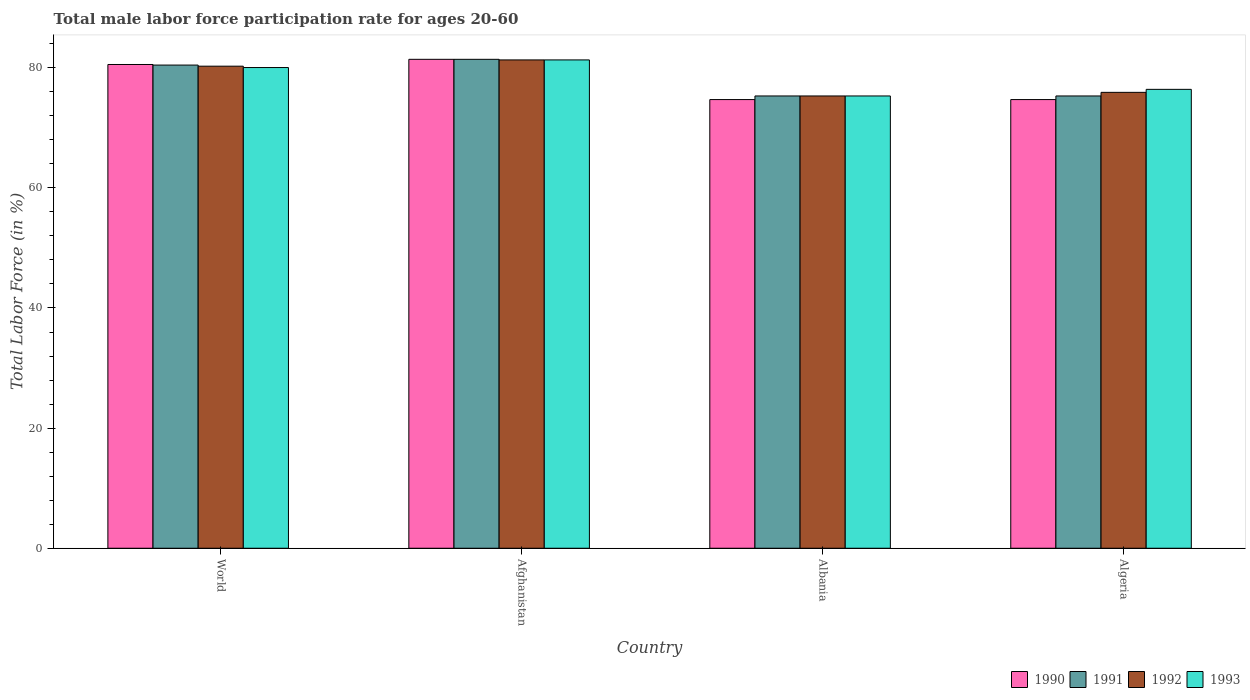How many groups of bars are there?
Provide a succinct answer. 4. Are the number of bars on each tick of the X-axis equal?
Keep it short and to the point. Yes. How many bars are there on the 4th tick from the right?
Your answer should be compact. 4. What is the label of the 3rd group of bars from the left?
Keep it short and to the point. Albania. In how many cases, is the number of bars for a given country not equal to the number of legend labels?
Make the answer very short. 0. What is the male labor force participation rate in 1991 in World?
Offer a terse response. 80.44. Across all countries, what is the maximum male labor force participation rate in 1993?
Offer a very short reply. 81.3. Across all countries, what is the minimum male labor force participation rate in 1990?
Offer a very short reply. 74.7. In which country was the male labor force participation rate in 1993 maximum?
Give a very brief answer. Afghanistan. In which country was the male labor force participation rate in 1992 minimum?
Keep it short and to the point. Albania. What is the total male labor force participation rate in 1992 in the graph?
Provide a succinct answer. 312.76. What is the difference between the male labor force participation rate in 1990 in Algeria and that in World?
Your answer should be very brief. -5.84. What is the difference between the male labor force participation rate in 1990 in World and the male labor force participation rate in 1992 in Albania?
Provide a succinct answer. 5.24. What is the average male labor force participation rate in 1993 per country?
Ensure brevity in your answer.  78.26. What is the difference between the male labor force participation rate of/in 1991 and male labor force participation rate of/in 1992 in Algeria?
Ensure brevity in your answer.  -0.6. In how many countries, is the male labor force participation rate in 1991 greater than 80 %?
Give a very brief answer. 2. What is the ratio of the male labor force participation rate in 1992 in Afghanistan to that in Albania?
Keep it short and to the point. 1.08. Is the male labor force participation rate in 1993 in Algeria less than that in World?
Your answer should be very brief. Yes. What is the difference between the highest and the second highest male labor force participation rate in 1991?
Your response must be concise. -0.96. In how many countries, is the male labor force participation rate in 1993 greater than the average male labor force participation rate in 1993 taken over all countries?
Give a very brief answer. 2. Is it the case that in every country, the sum of the male labor force participation rate in 1990 and male labor force participation rate in 1992 is greater than the sum of male labor force participation rate in 1991 and male labor force participation rate in 1993?
Keep it short and to the point. No. What does the 4th bar from the right in Albania represents?
Your answer should be very brief. 1990. How many countries are there in the graph?
Your response must be concise. 4. What is the difference between two consecutive major ticks on the Y-axis?
Ensure brevity in your answer.  20. Are the values on the major ticks of Y-axis written in scientific E-notation?
Keep it short and to the point. No. Does the graph contain any zero values?
Your answer should be very brief. No. How are the legend labels stacked?
Offer a terse response. Horizontal. What is the title of the graph?
Give a very brief answer. Total male labor force participation rate for ages 20-60. What is the label or title of the Y-axis?
Your answer should be compact. Total Labor Force (in %). What is the Total Labor Force (in %) of 1990 in World?
Your answer should be very brief. 80.54. What is the Total Labor Force (in %) in 1991 in World?
Offer a very short reply. 80.44. What is the Total Labor Force (in %) in 1992 in World?
Offer a terse response. 80.26. What is the Total Labor Force (in %) in 1993 in World?
Your answer should be very brief. 80.03. What is the Total Labor Force (in %) in 1990 in Afghanistan?
Your response must be concise. 81.4. What is the Total Labor Force (in %) in 1991 in Afghanistan?
Provide a succinct answer. 81.4. What is the Total Labor Force (in %) of 1992 in Afghanistan?
Offer a very short reply. 81.3. What is the Total Labor Force (in %) in 1993 in Afghanistan?
Your answer should be compact. 81.3. What is the Total Labor Force (in %) in 1990 in Albania?
Your answer should be very brief. 74.7. What is the Total Labor Force (in %) in 1991 in Albania?
Your answer should be compact. 75.3. What is the Total Labor Force (in %) in 1992 in Albania?
Your answer should be compact. 75.3. What is the Total Labor Force (in %) in 1993 in Albania?
Give a very brief answer. 75.3. What is the Total Labor Force (in %) in 1990 in Algeria?
Your answer should be very brief. 74.7. What is the Total Labor Force (in %) of 1991 in Algeria?
Your answer should be very brief. 75.3. What is the Total Labor Force (in %) in 1992 in Algeria?
Your answer should be very brief. 75.9. What is the Total Labor Force (in %) in 1993 in Algeria?
Ensure brevity in your answer.  76.4. Across all countries, what is the maximum Total Labor Force (in %) of 1990?
Your answer should be compact. 81.4. Across all countries, what is the maximum Total Labor Force (in %) in 1991?
Give a very brief answer. 81.4. Across all countries, what is the maximum Total Labor Force (in %) in 1992?
Offer a terse response. 81.3. Across all countries, what is the maximum Total Labor Force (in %) in 1993?
Give a very brief answer. 81.3. Across all countries, what is the minimum Total Labor Force (in %) of 1990?
Your response must be concise. 74.7. Across all countries, what is the minimum Total Labor Force (in %) in 1991?
Offer a terse response. 75.3. Across all countries, what is the minimum Total Labor Force (in %) in 1992?
Offer a terse response. 75.3. Across all countries, what is the minimum Total Labor Force (in %) of 1993?
Make the answer very short. 75.3. What is the total Total Labor Force (in %) of 1990 in the graph?
Your response must be concise. 311.34. What is the total Total Labor Force (in %) in 1991 in the graph?
Offer a very short reply. 312.44. What is the total Total Labor Force (in %) of 1992 in the graph?
Give a very brief answer. 312.76. What is the total Total Labor Force (in %) of 1993 in the graph?
Provide a short and direct response. 313.03. What is the difference between the Total Labor Force (in %) in 1990 in World and that in Afghanistan?
Provide a succinct answer. -0.86. What is the difference between the Total Labor Force (in %) of 1991 in World and that in Afghanistan?
Your response must be concise. -0.96. What is the difference between the Total Labor Force (in %) of 1992 in World and that in Afghanistan?
Your response must be concise. -1.04. What is the difference between the Total Labor Force (in %) in 1993 in World and that in Afghanistan?
Offer a terse response. -1.27. What is the difference between the Total Labor Force (in %) of 1990 in World and that in Albania?
Provide a succinct answer. 5.84. What is the difference between the Total Labor Force (in %) of 1991 in World and that in Albania?
Make the answer very short. 5.14. What is the difference between the Total Labor Force (in %) of 1992 in World and that in Albania?
Make the answer very short. 4.96. What is the difference between the Total Labor Force (in %) of 1993 in World and that in Albania?
Keep it short and to the point. 4.73. What is the difference between the Total Labor Force (in %) of 1990 in World and that in Algeria?
Give a very brief answer. 5.84. What is the difference between the Total Labor Force (in %) in 1991 in World and that in Algeria?
Ensure brevity in your answer.  5.14. What is the difference between the Total Labor Force (in %) in 1992 in World and that in Algeria?
Make the answer very short. 4.36. What is the difference between the Total Labor Force (in %) of 1993 in World and that in Algeria?
Keep it short and to the point. 3.63. What is the difference between the Total Labor Force (in %) in 1992 in Afghanistan and that in Albania?
Your answer should be compact. 6. What is the difference between the Total Labor Force (in %) in 1993 in Afghanistan and that in Albania?
Ensure brevity in your answer.  6. What is the difference between the Total Labor Force (in %) in 1992 in Afghanistan and that in Algeria?
Provide a short and direct response. 5.4. What is the difference between the Total Labor Force (in %) in 1993 in Afghanistan and that in Algeria?
Your answer should be very brief. 4.9. What is the difference between the Total Labor Force (in %) in 1991 in Albania and that in Algeria?
Offer a very short reply. 0. What is the difference between the Total Labor Force (in %) of 1992 in Albania and that in Algeria?
Provide a short and direct response. -0.6. What is the difference between the Total Labor Force (in %) of 1993 in Albania and that in Algeria?
Your answer should be very brief. -1.1. What is the difference between the Total Labor Force (in %) in 1990 in World and the Total Labor Force (in %) in 1991 in Afghanistan?
Offer a very short reply. -0.86. What is the difference between the Total Labor Force (in %) in 1990 in World and the Total Labor Force (in %) in 1992 in Afghanistan?
Ensure brevity in your answer.  -0.76. What is the difference between the Total Labor Force (in %) of 1990 in World and the Total Labor Force (in %) of 1993 in Afghanistan?
Offer a very short reply. -0.76. What is the difference between the Total Labor Force (in %) of 1991 in World and the Total Labor Force (in %) of 1992 in Afghanistan?
Offer a terse response. -0.86. What is the difference between the Total Labor Force (in %) in 1991 in World and the Total Labor Force (in %) in 1993 in Afghanistan?
Keep it short and to the point. -0.86. What is the difference between the Total Labor Force (in %) of 1992 in World and the Total Labor Force (in %) of 1993 in Afghanistan?
Your response must be concise. -1.04. What is the difference between the Total Labor Force (in %) of 1990 in World and the Total Labor Force (in %) of 1991 in Albania?
Keep it short and to the point. 5.24. What is the difference between the Total Labor Force (in %) in 1990 in World and the Total Labor Force (in %) in 1992 in Albania?
Make the answer very short. 5.24. What is the difference between the Total Labor Force (in %) of 1990 in World and the Total Labor Force (in %) of 1993 in Albania?
Ensure brevity in your answer.  5.24. What is the difference between the Total Labor Force (in %) of 1991 in World and the Total Labor Force (in %) of 1992 in Albania?
Provide a succinct answer. 5.14. What is the difference between the Total Labor Force (in %) in 1991 in World and the Total Labor Force (in %) in 1993 in Albania?
Your response must be concise. 5.14. What is the difference between the Total Labor Force (in %) of 1992 in World and the Total Labor Force (in %) of 1993 in Albania?
Your answer should be very brief. 4.96. What is the difference between the Total Labor Force (in %) of 1990 in World and the Total Labor Force (in %) of 1991 in Algeria?
Your answer should be very brief. 5.24. What is the difference between the Total Labor Force (in %) of 1990 in World and the Total Labor Force (in %) of 1992 in Algeria?
Keep it short and to the point. 4.64. What is the difference between the Total Labor Force (in %) in 1990 in World and the Total Labor Force (in %) in 1993 in Algeria?
Make the answer very short. 4.14. What is the difference between the Total Labor Force (in %) of 1991 in World and the Total Labor Force (in %) of 1992 in Algeria?
Offer a terse response. 4.54. What is the difference between the Total Labor Force (in %) in 1991 in World and the Total Labor Force (in %) in 1993 in Algeria?
Provide a short and direct response. 4.04. What is the difference between the Total Labor Force (in %) in 1992 in World and the Total Labor Force (in %) in 1993 in Algeria?
Give a very brief answer. 3.86. What is the difference between the Total Labor Force (in %) in 1990 in Afghanistan and the Total Labor Force (in %) in 1991 in Albania?
Ensure brevity in your answer.  6.1. What is the difference between the Total Labor Force (in %) of 1991 in Afghanistan and the Total Labor Force (in %) of 1992 in Albania?
Keep it short and to the point. 6.1. What is the difference between the Total Labor Force (in %) in 1992 in Afghanistan and the Total Labor Force (in %) in 1993 in Algeria?
Offer a terse response. 4.9. What is the difference between the Total Labor Force (in %) in 1990 in Albania and the Total Labor Force (in %) in 1991 in Algeria?
Offer a very short reply. -0.6. What is the difference between the Total Labor Force (in %) of 1990 in Albania and the Total Labor Force (in %) of 1992 in Algeria?
Provide a succinct answer. -1.2. What is the difference between the Total Labor Force (in %) in 1990 in Albania and the Total Labor Force (in %) in 1993 in Algeria?
Offer a terse response. -1.7. What is the average Total Labor Force (in %) of 1990 per country?
Make the answer very short. 77.83. What is the average Total Labor Force (in %) of 1991 per country?
Your answer should be compact. 78.11. What is the average Total Labor Force (in %) in 1992 per country?
Provide a succinct answer. 78.19. What is the average Total Labor Force (in %) in 1993 per country?
Offer a terse response. 78.26. What is the difference between the Total Labor Force (in %) in 1990 and Total Labor Force (in %) in 1991 in World?
Your answer should be compact. 0.1. What is the difference between the Total Labor Force (in %) in 1990 and Total Labor Force (in %) in 1992 in World?
Your answer should be very brief. 0.28. What is the difference between the Total Labor Force (in %) of 1990 and Total Labor Force (in %) of 1993 in World?
Your answer should be compact. 0.51. What is the difference between the Total Labor Force (in %) in 1991 and Total Labor Force (in %) in 1992 in World?
Ensure brevity in your answer.  0.18. What is the difference between the Total Labor Force (in %) of 1991 and Total Labor Force (in %) of 1993 in World?
Your response must be concise. 0.41. What is the difference between the Total Labor Force (in %) in 1992 and Total Labor Force (in %) in 1993 in World?
Keep it short and to the point. 0.23. What is the difference between the Total Labor Force (in %) of 1990 and Total Labor Force (in %) of 1991 in Afghanistan?
Your answer should be compact. 0. What is the difference between the Total Labor Force (in %) of 1990 and Total Labor Force (in %) of 1992 in Afghanistan?
Make the answer very short. 0.1. What is the difference between the Total Labor Force (in %) in 1991 and Total Labor Force (in %) in 1992 in Afghanistan?
Ensure brevity in your answer.  0.1. What is the difference between the Total Labor Force (in %) in 1991 and Total Labor Force (in %) in 1993 in Afghanistan?
Offer a terse response. 0.1. What is the difference between the Total Labor Force (in %) of 1990 and Total Labor Force (in %) of 1992 in Albania?
Ensure brevity in your answer.  -0.6. What is the difference between the Total Labor Force (in %) in 1991 and Total Labor Force (in %) in 1992 in Albania?
Your response must be concise. 0. What is the difference between the Total Labor Force (in %) of 1992 and Total Labor Force (in %) of 1993 in Albania?
Make the answer very short. 0. What is the difference between the Total Labor Force (in %) in 1990 and Total Labor Force (in %) in 1991 in Algeria?
Your response must be concise. -0.6. What is the difference between the Total Labor Force (in %) in 1990 and Total Labor Force (in %) in 1992 in Algeria?
Your response must be concise. -1.2. What is the difference between the Total Labor Force (in %) in 1991 and Total Labor Force (in %) in 1992 in Algeria?
Your response must be concise. -0.6. What is the difference between the Total Labor Force (in %) in 1992 and Total Labor Force (in %) in 1993 in Algeria?
Give a very brief answer. -0.5. What is the ratio of the Total Labor Force (in %) of 1991 in World to that in Afghanistan?
Give a very brief answer. 0.99. What is the ratio of the Total Labor Force (in %) in 1992 in World to that in Afghanistan?
Provide a succinct answer. 0.99. What is the ratio of the Total Labor Force (in %) in 1993 in World to that in Afghanistan?
Your response must be concise. 0.98. What is the ratio of the Total Labor Force (in %) in 1990 in World to that in Albania?
Provide a succinct answer. 1.08. What is the ratio of the Total Labor Force (in %) of 1991 in World to that in Albania?
Provide a succinct answer. 1.07. What is the ratio of the Total Labor Force (in %) in 1992 in World to that in Albania?
Offer a very short reply. 1.07. What is the ratio of the Total Labor Force (in %) in 1993 in World to that in Albania?
Your answer should be compact. 1.06. What is the ratio of the Total Labor Force (in %) of 1990 in World to that in Algeria?
Keep it short and to the point. 1.08. What is the ratio of the Total Labor Force (in %) in 1991 in World to that in Algeria?
Your answer should be compact. 1.07. What is the ratio of the Total Labor Force (in %) of 1992 in World to that in Algeria?
Make the answer very short. 1.06. What is the ratio of the Total Labor Force (in %) in 1993 in World to that in Algeria?
Your answer should be very brief. 1.05. What is the ratio of the Total Labor Force (in %) in 1990 in Afghanistan to that in Albania?
Make the answer very short. 1.09. What is the ratio of the Total Labor Force (in %) in 1991 in Afghanistan to that in Albania?
Ensure brevity in your answer.  1.08. What is the ratio of the Total Labor Force (in %) in 1992 in Afghanistan to that in Albania?
Keep it short and to the point. 1.08. What is the ratio of the Total Labor Force (in %) in 1993 in Afghanistan to that in Albania?
Make the answer very short. 1.08. What is the ratio of the Total Labor Force (in %) in 1990 in Afghanistan to that in Algeria?
Your answer should be compact. 1.09. What is the ratio of the Total Labor Force (in %) of 1991 in Afghanistan to that in Algeria?
Make the answer very short. 1.08. What is the ratio of the Total Labor Force (in %) in 1992 in Afghanistan to that in Algeria?
Offer a terse response. 1.07. What is the ratio of the Total Labor Force (in %) in 1993 in Afghanistan to that in Algeria?
Make the answer very short. 1.06. What is the ratio of the Total Labor Force (in %) in 1990 in Albania to that in Algeria?
Ensure brevity in your answer.  1. What is the ratio of the Total Labor Force (in %) in 1991 in Albania to that in Algeria?
Offer a terse response. 1. What is the ratio of the Total Labor Force (in %) of 1992 in Albania to that in Algeria?
Your response must be concise. 0.99. What is the ratio of the Total Labor Force (in %) in 1993 in Albania to that in Algeria?
Your answer should be very brief. 0.99. What is the difference between the highest and the second highest Total Labor Force (in %) in 1990?
Provide a succinct answer. 0.86. What is the difference between the highest and the second highest Total Labor Force (in %) of 1991?
Offer a very short reply. 0.96. What is the difference between the highest and the second highest Total Labor Force (in %) of 1992?
Offer a very short reply. 1.04. What is the difference between the highest and the second highest Total Labor Force (in %) in 1993?
Your answer should be very brief. 1.27. What is the difference between the highest and the lowest Total Labor Force (in %) of 1990?
Keep it short and to the point. 6.7. What is the difference between the highest and the lowest Total Labor Force (in %) of 1993?
Offer a terse response. 6. 